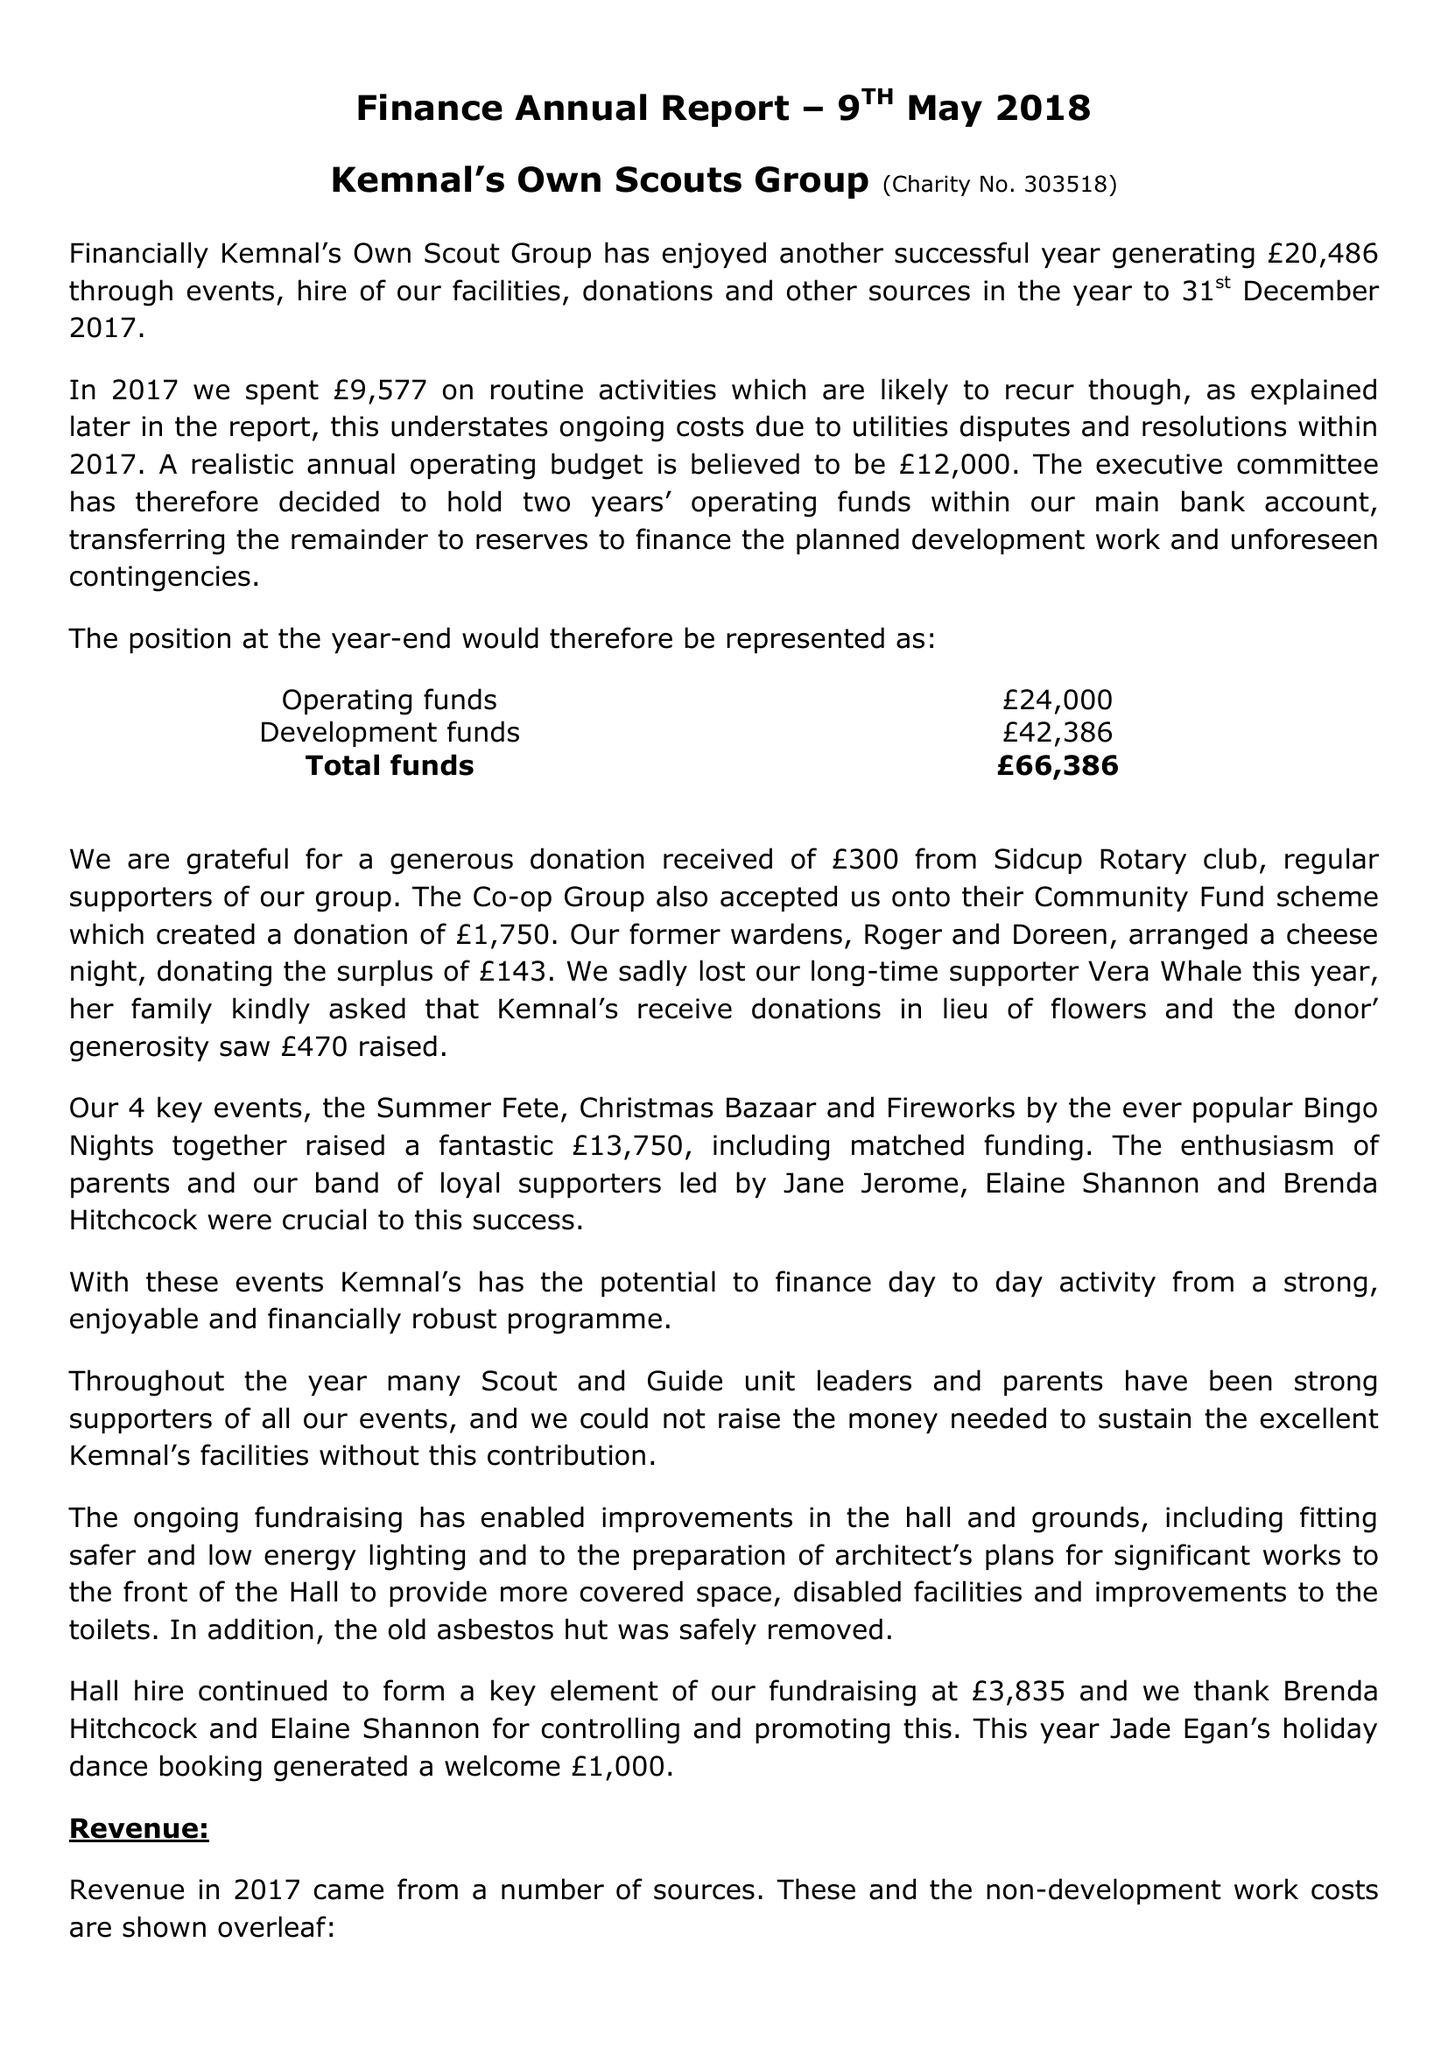What is the value for the income_annually_in_british_pounds?
Answer the question using a single word or phrase. 25799.00 